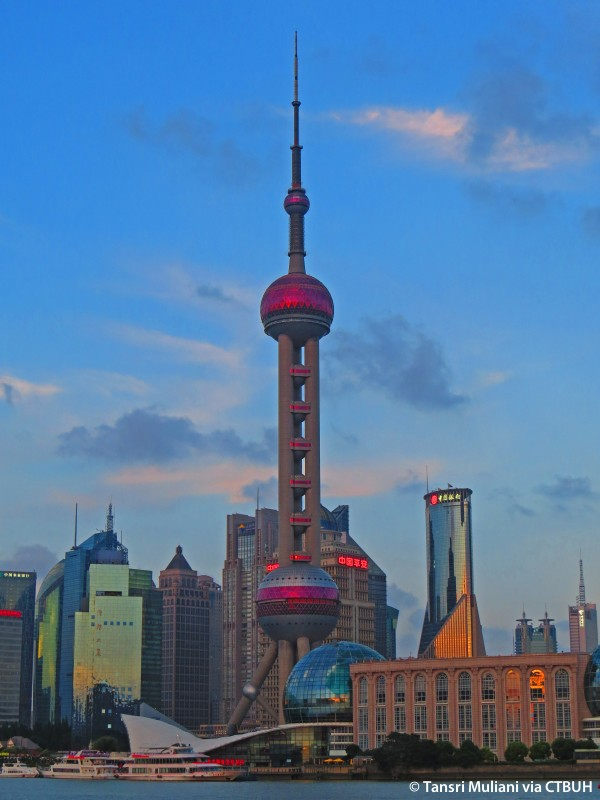How do locals and tourists view the significance of the Oriental Pearl Tower? For locals, the Oriental Pearl Tower is a symbol of pride and a testament to Shanghai's rapid development and modernity. It represents the city's ambitions and achievements, serving as a reminder of its past, present, and future. Many locals cherish the tower for its cultural and social significance, often visiting its observation decks and utilizing its facilities such as the museum and restaurants. For tourists, the tower is an iconic landmark and a must-visit destination. It offers a unique opportunity to experience panoramic views of Shanghai's skyline, delve into the city's history, and enjoy various entertainment options. The tower's distinct design and prominent presence in the city's landscape make it a favorite subject for photographs and a memorable highlight of their visit to Shanghai. 